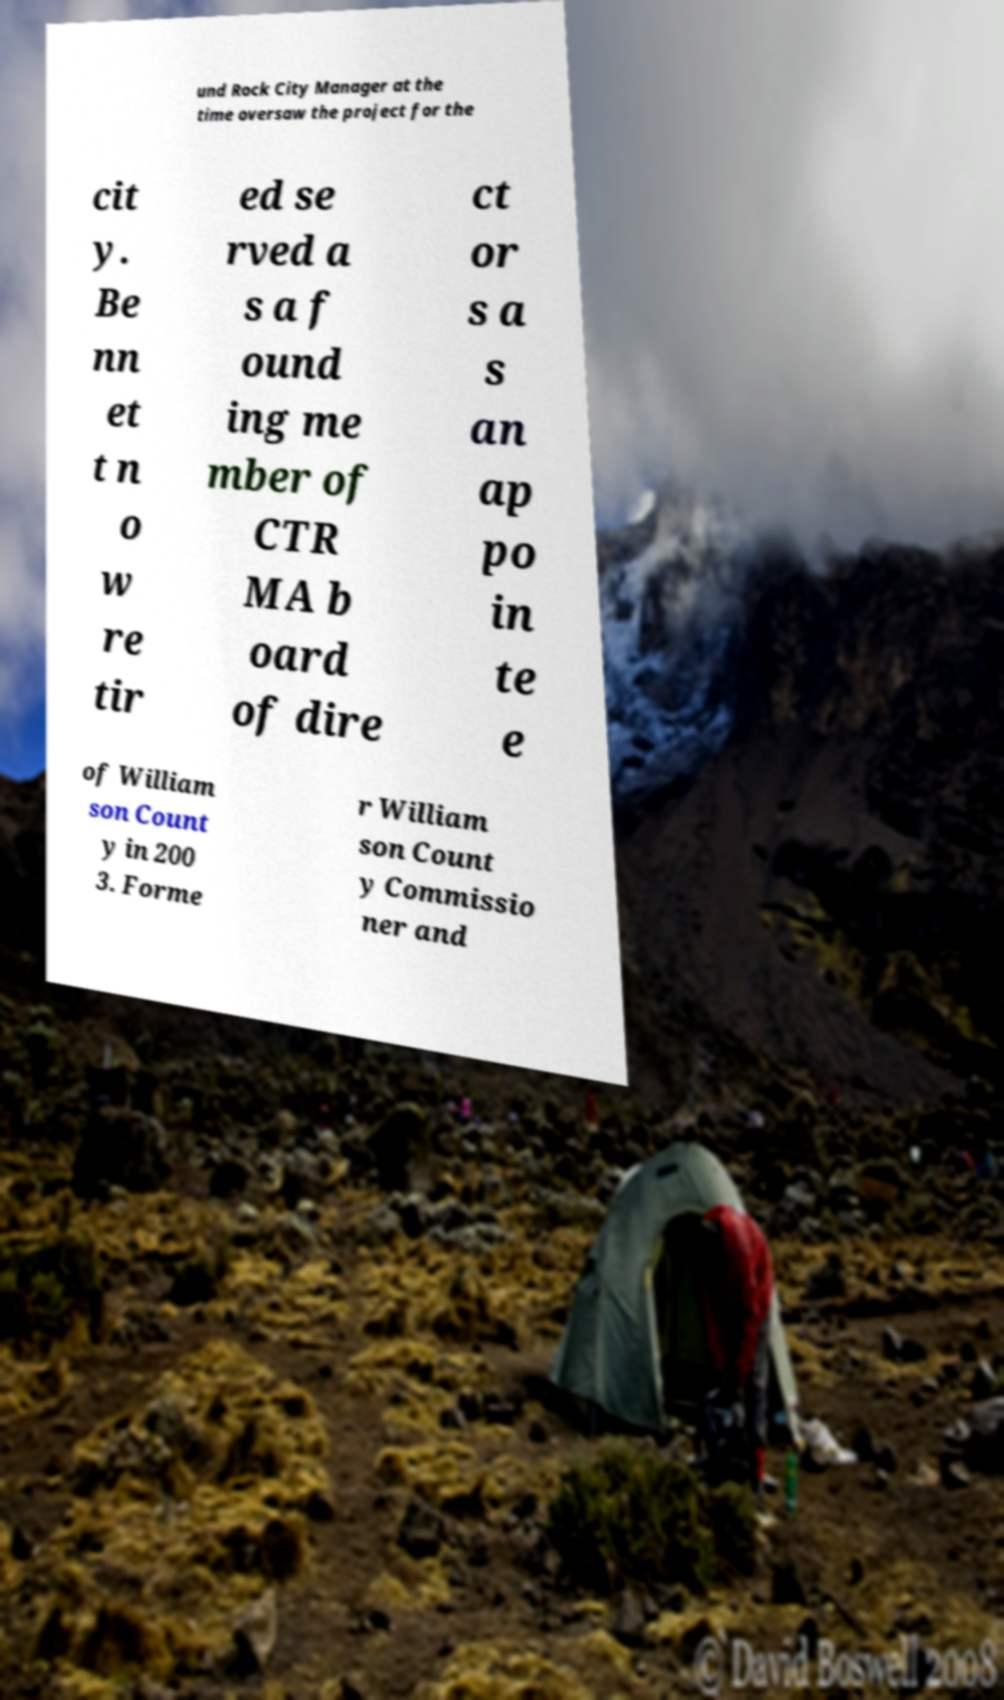What messages or text are displayed in this image? I need them in a readable, typed format. und Rock City Manager at the time oversaw the project for the cit y. Be nn et t n o w re tir ed se rved a s a f ound ing me mber of CTR MA b oard of dire ct or s a s an ap po in te e of William son Count y in 200 3. Forme r William son Count y Commissio ner and 